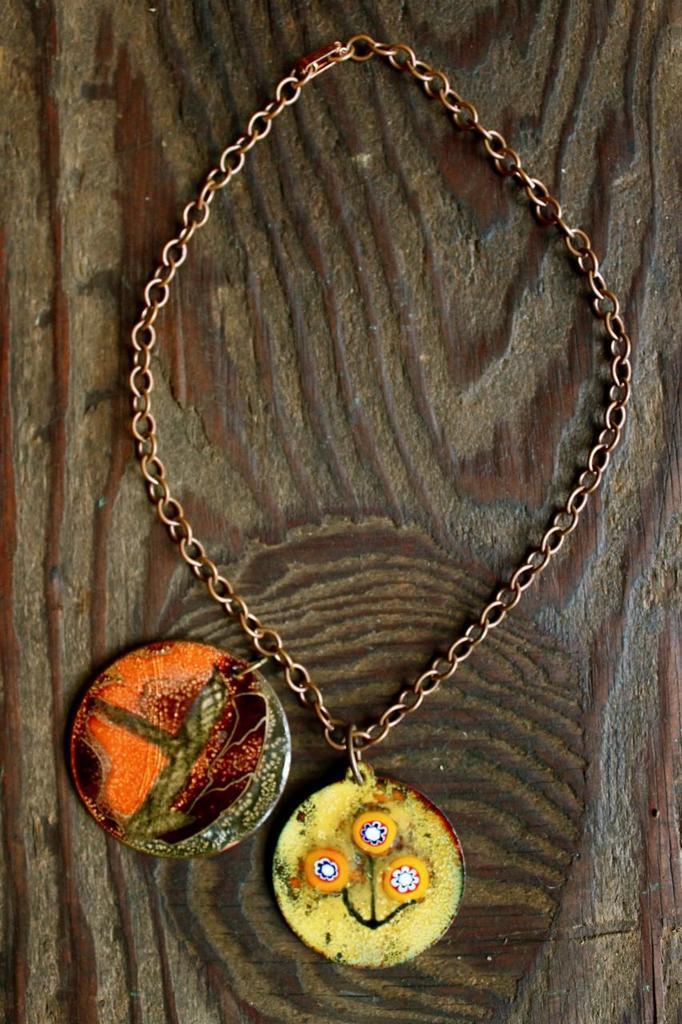In one or two sentences, can you explain what this image depicts? In the foreground of this image, to a chain, there are two lockets which is placed on a wooden surface. 